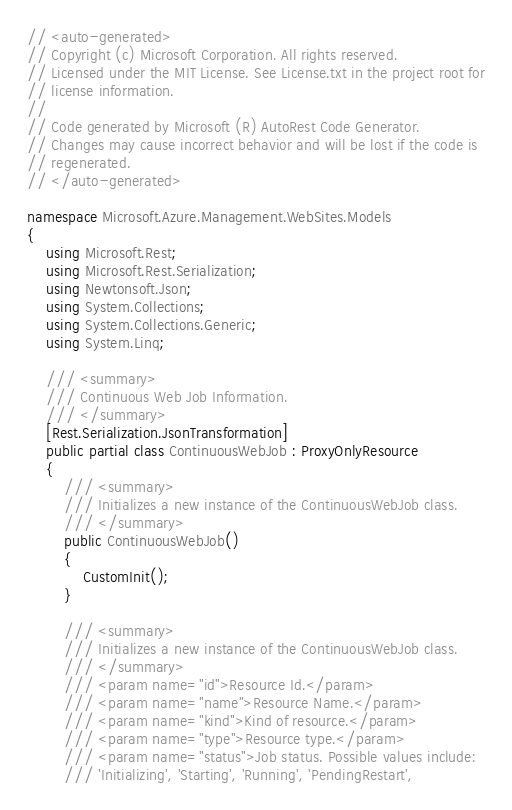<code> <loc_0><loc_0><loc_500><loc_500><_C#_>// <auto-generated>
// Copyright (c) Microsoft Corporation. All rights reserved.
// Licensed under the MIT License. See License.txt in the project root for
// license information.
//
// Code generated by Microsoft (R) AutoRest Code Generator.
// Changes may cause incorrect behavior and will be lost if the code is
// regenerated.
// </auto-generated>

namespace Microsoft.Azure.Management.WebSites.Models
{
    using Microsoft.Rest;
    using Microsoft.Rest.Serialization;
    using Newtonsoft.Json;
    using System.Collections;
    using System.Collections.Generic;
    using System.Linq;

    /// <summary>
    /// Continuous Web Job Information.
    /// </summary>
    [Rest.Serialization.JsonTransformation]
    public partial class ContinuousWebJob : ProxyOnlyResource
    {
        /// <summary>
        /// Initializes a new instance of the ContinuousWebJob class.
        /// </summary>
        public ContinuousWebJob()
        {
            CustomInit();
        }

        /// <summary>
        /// Initializes a new instance of the ContinuousWebJob class.
        /// </summary>
        /// <param name="id">Resource Id.</param>
        /// <param name="name">Resource Name.</param>
        /// <param name="kind">Kind of resource.</param>
        /// <param name="type">Resource type.</param>
        /// <param name="status">Job status. Possible values include:
        /// 'Initializing', 'Starting', 'Running', 'PendingRestart',</code> 